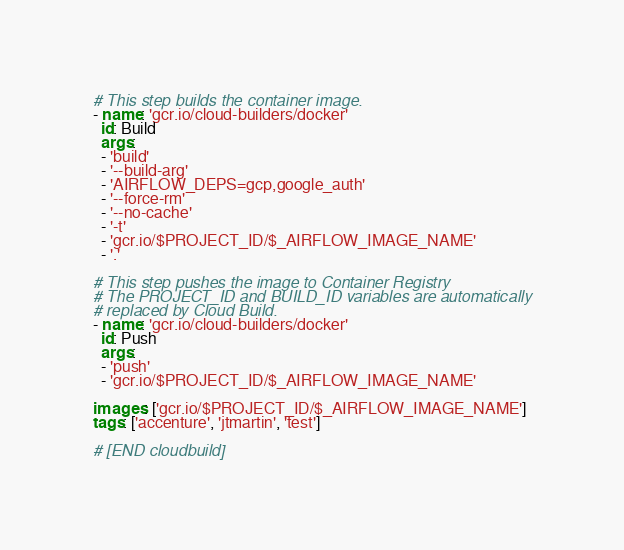Convert code to text. <code><loc_0><loc_0><loc_500><loc_500><_YAML_>
# This step builds the container image.
- name: 'gcr.io/cloud-builders/docker'
  id: Build
  args:
  - 'build'
  - '--build-arg' 
  - 'AIRFLOW_DEPS=gcp,google_auth'
  - '--force-rm'
  - '--no-cache'
  - '-t'
  - 'gcr.io/$PROJECT_ID/$_AIRFLOW_IMAGE_NAME'
  - '.'

# This step pushes the image to Container Registry
# The PROJECT_ID and BUILD_ID variables are automatically
# replaced by Cloud Build.
- name: 'gcr.io/cloud-builders/docker'
  id: Push
  args:
  - 'push'
  - 'gcr.io/$PROJECT_ID/$_AIRFLOW_IMAGE_NAME'
  
images: ['gcr.io/$PROJECT_ID/$_AIRFLOW_IMAGE_NAME']
tags: ['accenture', 'jtmartin', 'test']
  
# [END cloudbuild]
</code> 